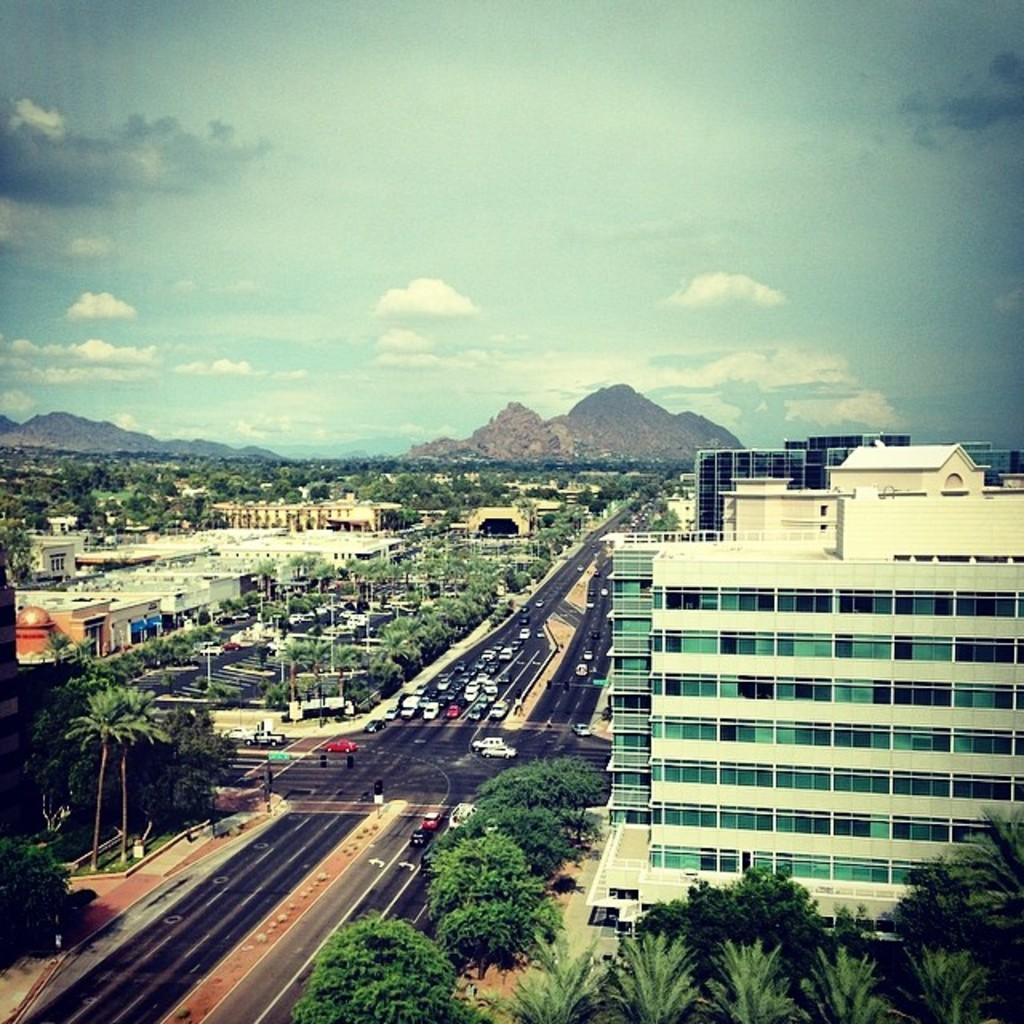What type of structures can be seen in the image? There are buildings in the image. What else can be seen in the image besides buildings? There are trees and vehicles on the road in the image. Where is the road located in the image? The road is in the middle of the image. What can be seen in the background of the image? There is a sky visible in the background of the image. What type of spark can be seen coming from the trees in the image? There is no spark present in the image; it features buildings, trees, vehicles, and a road. 